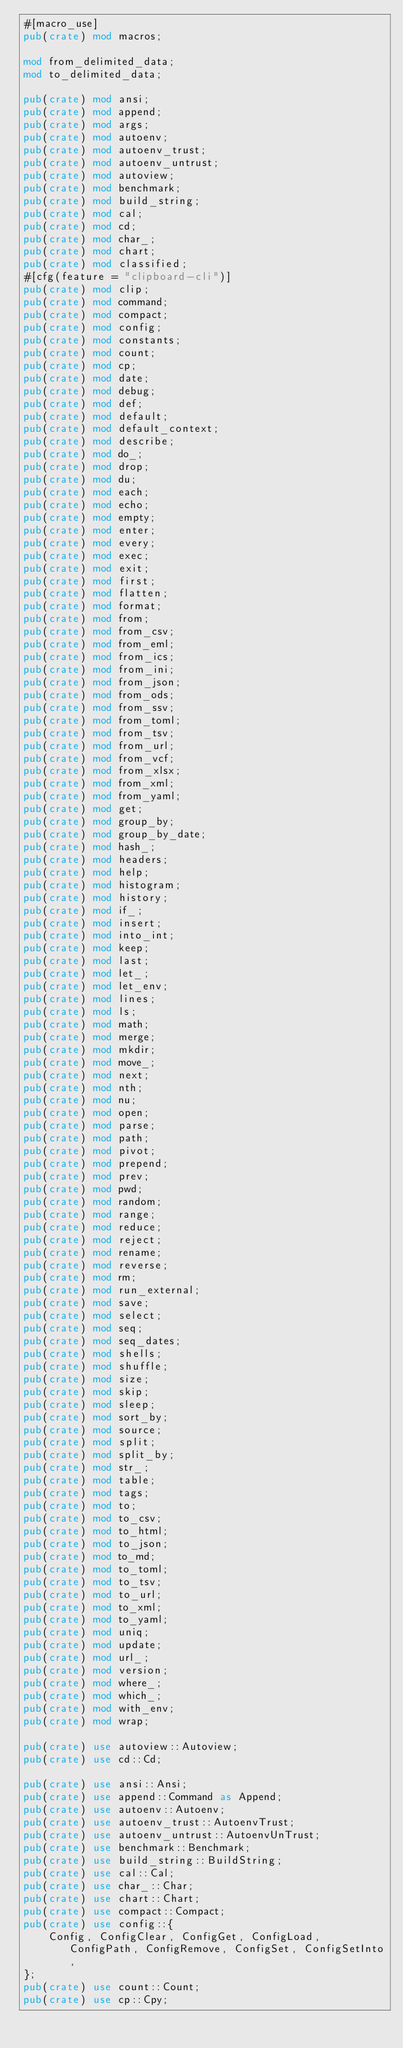<code> <loc_0><loc_0><loc_500><loc_500><_Rust_>#[macro_use]
pub(crate) mod macros;

mod from_delimited_data;
mod to_delimited_data;

pub(crate) mod ansi;
pub(crate) mod append;
pub(crate) mod args;
pub(crate) mod autoenv;
pub(crate) mod autoenv_trust;
pub(crate) mod autoenv_untrust;
pub(crate) mod autoview;
pub(crate) mod benchmark;
pub(crate) mod build_string;
pub(crate) mod cal;
pub(crate) mod cd;
pub(crate) mod char_;
pub(crate) mod chart;
pub(crate) mod classified;
#[cfg(feature = "clipboard-cli")]
pub(crate) mod clip;
pub(crate) mod command;
pub(crate) mod compact;
pub(crate) mod config;
pub(crate) mod constants;
pub(crate) mod count;
pub(crate) mod cp;
pub(crate) mod date;
pub(crate) mod debug;
pub(crate) mod def;
pub(crate) mod default;
pub(crate) mod default_context;
pub(crate) mod describe;
pub(crate) mod do_;
pub(crate) mod drop;
pub(crate) mod du;
pub(crate) mod each;
pub(crate) mod echo;
pub(crate) mod empty;
pub(crate) mod enter;
pub(crate) mod every;
pub(crate) mod exec;
pub(crate) mod exit;
pub(crate) mod first;
pub(crate) mod flatten;
pub(crate) mod format;
pub(crate) mod from;
pub(crate) mod from_csv;
pub(crate) mod from_eml;
pub(crate) mod from_ics;
pub(crate) mod from_ini;
pub(crate) mod from_json;
pub(crate) mod from_ods;
pub(crate) mod from_ssv;
pub(crate) mod from_toml;
pub(crate) mod from_tsv;
pub(crate) mod from_url;
pub(crate) mod from_vcf;
pub(crate) mod from_xlsx;
pub(crate) mod from_xml;
pub(crate) mod from_yaml;
pub(crate) mod get;
pub(crate) mod group_by;
pub(crate) mod group_by_date;
pub(crate) mod hash_;
pub(crate) mod headers;
pub(crate) mod help;
pub(crate) mod histogram;
pub(crate) mod history;
pub(crate) mod if_;
pub(crate) mod insert;
pub(crate) mod into_int;
pub(crate) mod keep;
pub(crate) mod last;
pub(crate) mod let_;
pub(crate) mod let_env;
pub(crate) mod lines;
pub(crate) mod ls;
pub(crate) mod math;
pub(crate) mod merge;
pub(crate) mod mkdir;
pub(crate) mod move_;
pub(crate) mod next;
pub(crate) mod nth;
pub(crate) mod nu;
pub(crate) mod open;
pub(crate) mod parse;
pub(crate) mod path;
pub(crate) mod pivot;
pub(crate) mod prepend;
pub(crate) mod prev;
pub(crate) mod pwd;
pub(crate) mod random;
pub(crate) mod range;
pub(crate) mod reduce;
pub(crate) mod reject;
pub(crate) mod rename;
pub(crate) mod reverse;
pub(crate) mod rm;
pub(crate) mod run_external;
pub(crate) mod save;
pub(crate) mod select;
pub(crate) mod seq;
pub(crate) mod seq_dates;
pub(crate) mod shells;
pub(crate) mod shuffle;
pub(crate) mod size;
pub(crate) mod skip;
pub(crate) mod sleep;
pub(crate) mod sort_by;
pub(crate) mod source;
pub(crate) mod split;
pub(crate) mod split_by;
pub(crate) mod str_;
pub(crate) mod table;
pub(crate) mod tags;
pub(crate) mod to;
pub(crate) mod to_csv;
pub(crate) mod to_html;
pub(crate) mod to_json;
pub(crate) mod to_md;
pub(crate) mod to_toml;
pub(crate) mod to_tsv;
pub(crate) mod to_url;
pub(crate) mod to_xml;
pub(crate) mod to_yaml;
pub(crate) mod uniq;
pub(crate) mod update;
pub(crate) mod url_;
pub(crate) mod version;
pub(crate) mod where_;
pub(crate) mod which_;
pub(crate) mod with_env;
pub(crate) mod wrap;

pub(crate) use autoview::Autoview;
pub(crate) use cd::Cd;

pub(crate) use ansi::Ansi;
pub(crate) use append::Command as Append;
pub(crate) use autoenv::Autoenv;
pub(crate) use autoenv_trust::AutoenvTrust;
pub(crate) use autoenv_untrust::AutoenvUnTrust;
pub(crate) use benchmark::Benchmark;
pub(crate) use build_string::BuildString;
pub(crate) use cal::Cal;
pub(crate) use char_::Char;
pub(crate) use chart::Chart;
pub(crate) use compact::Compact;
pub(crate) use config::{
    Config, ConfigClear, ConfigGet, ConfigLoad, ConfigPath, ConfigRemove, ConfigSet, ConfigSetInto,
};
pub(crate) use count::Count;
pub(crate) use cp::Cpy;</code> 